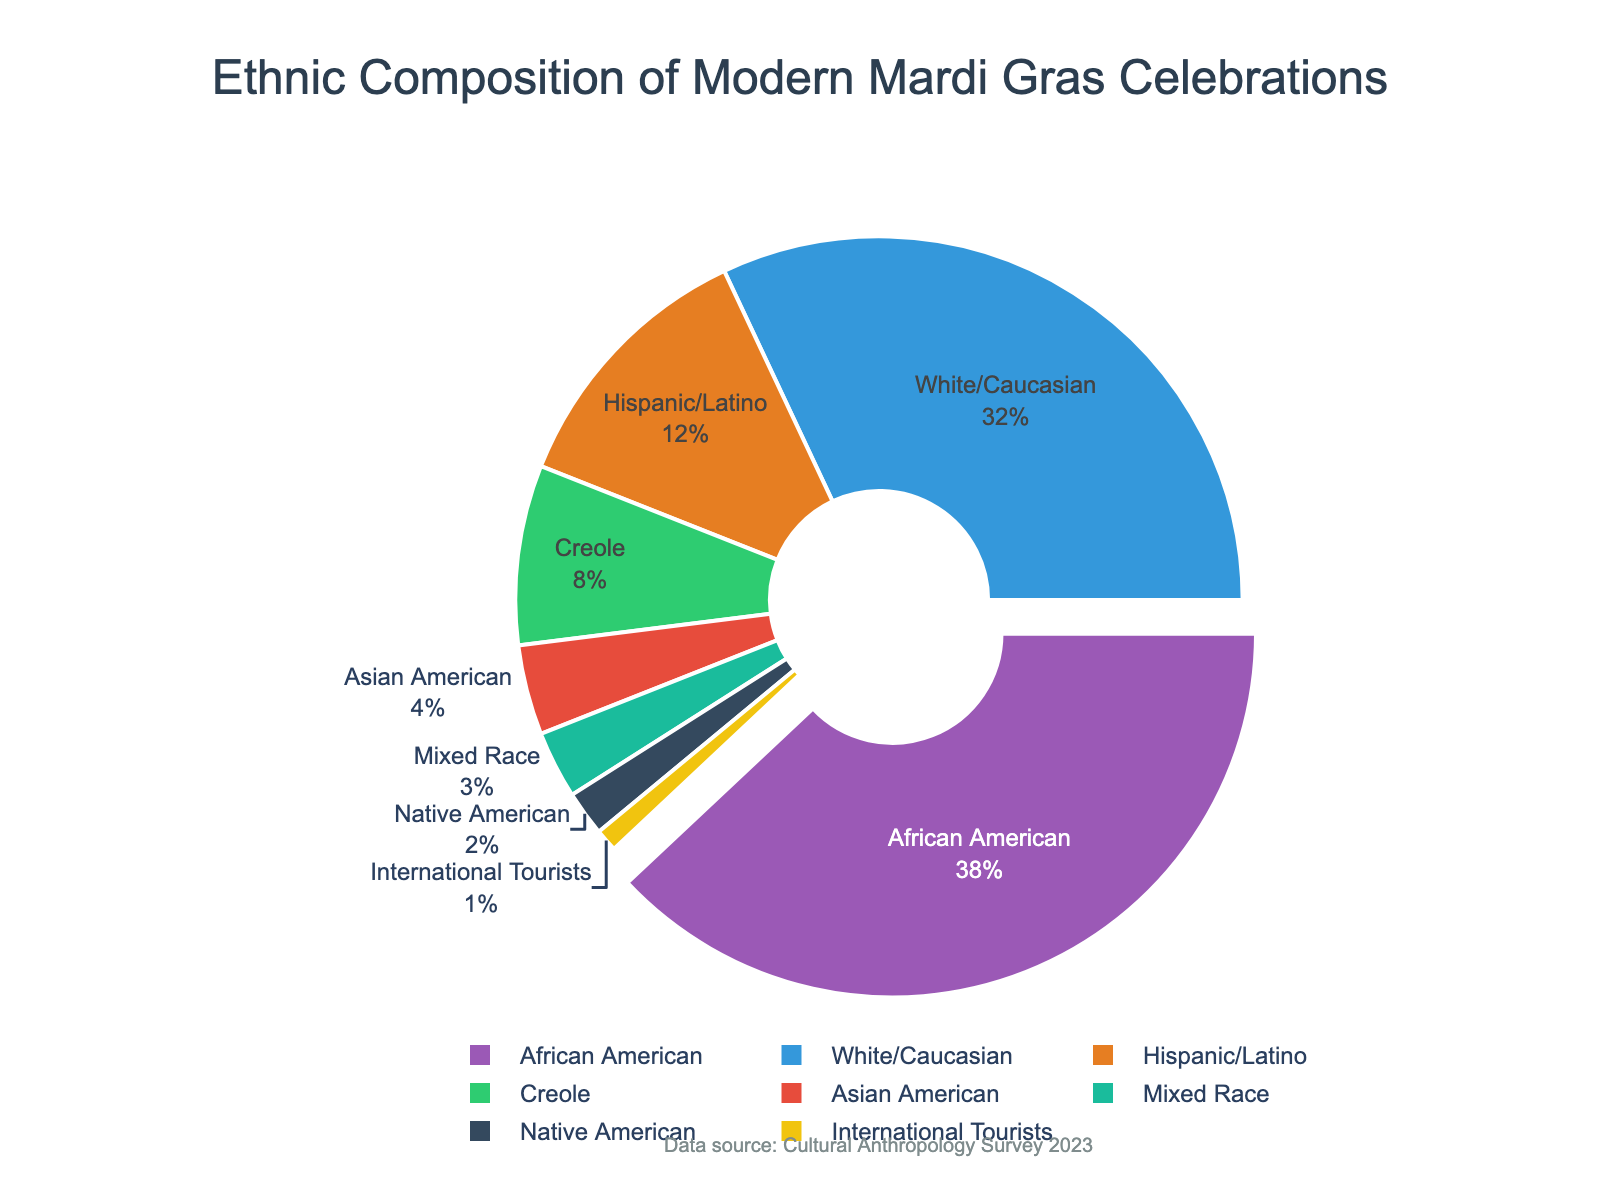Which ethnic group has the highest percentage of participants? Look for the segment that has the largest area in the pie chart. The "African American" segment is pulled out, indicating it has the highest percentage.
Answer: African American What is the combined percentage of White/Caucasian and Hispanic/Latino participants? Add the percentages of "White/Caucasian" (32%) and "Hispanic/Latino" (12%). 32% + 12% = 44%
Answer: 44% How does the percentage of Creole participants compare to that of Asian American participants? Compare the percentages of "Creole" (8%) and "Asian American" (4%). 8% is greater than 4%.
Answer: Creole has a higher percentage Among Mixed Race and International Tourists, which group has a higher percentage? Compare the percentages of "Mixed Race" (3%) and "International Tourists" (1%). 3% is greater than 1%.
Answer: Mixed Race What is the difference in percentage between African American and Native American participants? Subtract the percentage of "Native American" (2%) from that of "African American" (38%). 38% - 2% = 36%
Answer: 36% Which ethnic group represents the smallest percentage of participants? Look for the smallest segment in the pie chart. The "International Tourists" segment is the smallest.
Answer: International Tourists What is the total percentage of participants from minority groups (Hispanic/Latino, Creole, Asian American, Native American, Mixed Race)? Add the percentages of "Hispanic/Latino" (12%), "Creole" (8%), "Asian American" (4%), "Native American" (2%), and "Mixed Race" (3%). 12% + 8% + 4% + 2% + 3% = 29%
Answer: 29% How do the visual attributes of the "White/Caucasian" and "Creole" segments differ? Observe the size and color of the segments. The "White/Caucasian" segment is slightly larger and colored blue, while the "Creole" segment is smaller and colored green.
Answer: White/Caucasian is larger, colored blue; Creole is smaller, colored green 